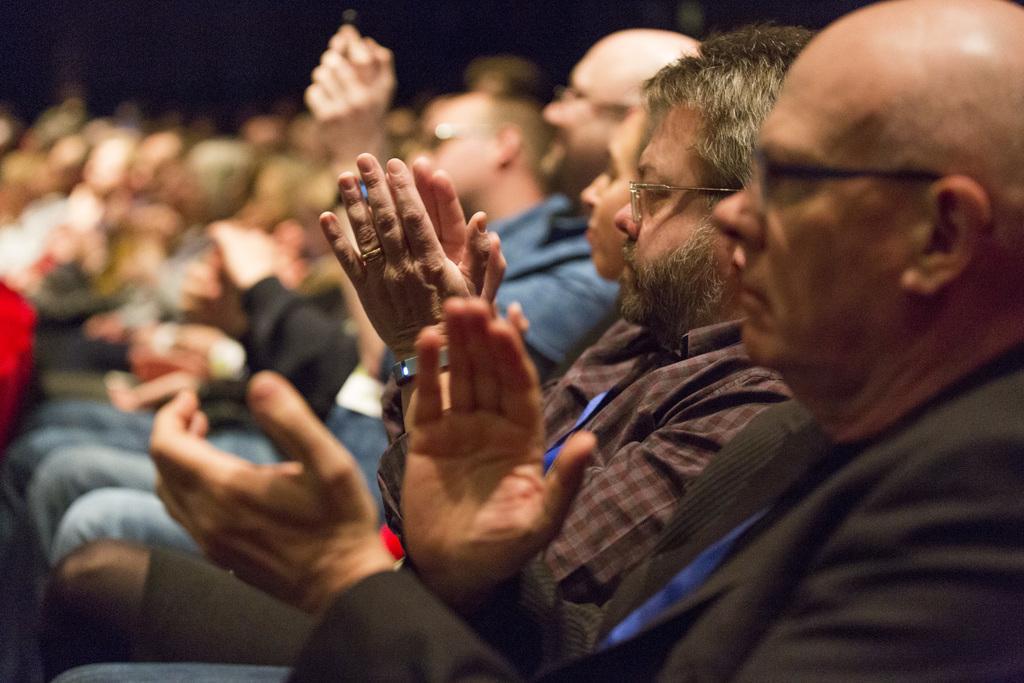In one or two sentences, can you explain what this image depicts? In this picture we can see a few people sitting on the chair. Background is blurry. 